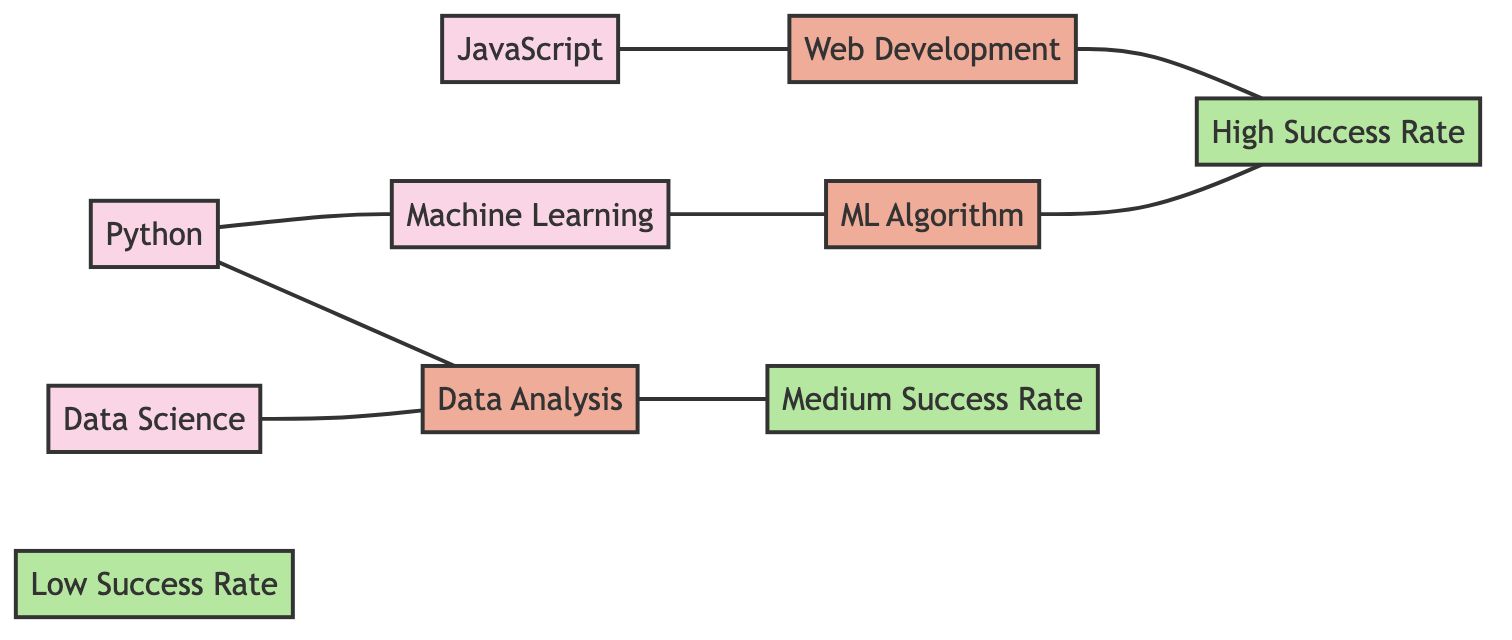What skill set is connected to Web Development? The diagram shows an edge connecting the node "JavaScript" to "Web Development," indicating a direct relationship. Therefore, the skill set that is connected to Web Development is JavaScript.
Answer: JavaScript How many skill sets are depicted in the diagram? By counting the number of nodes labeled as skill sets (JavaScript, Python, Data Science, Machine Learning), we find there are four distinct skill sets in total.
Answer: 4 Which project is linked to a High Success Rate? The diagram contains edges connecting "Web Development" and "ML Algorithm" to the "High Success Rate." Thus, "Web Development" and "ML Algorithm" are both linked to a High Success Rate.
Answer: Web Development, ML Algorithm What is the success rate of Data Analysis projects? An edge connects "Data Analysis" to "Medium Success Rate," denoting that projects in Data Analysis have a Medium Success Rate.
Answer: Medium Success Rate Describe the relationship between Python and Machine Learning. The diagram presents an edge connecting the nodes for Python and Machine Learning, indicating that there is a direct relationship between the two. Python is connected to Machine Learning.
Answer: Connected How many projects are associated with the skill set Data Science? The edge in the diagram shows that "Data Science" is linked to "Data Analysis," indicating that only one project is associated with this skill set.
Answer: 1 Which skill set is directly related to the ML Algorithm project? The diagram illustrates a direct edge from "Machine Learning" to "ML Algorithm," which indicates that the skill set directly related to the ML Algorithm project is Machine Learning.
Answer: Machine Learning 